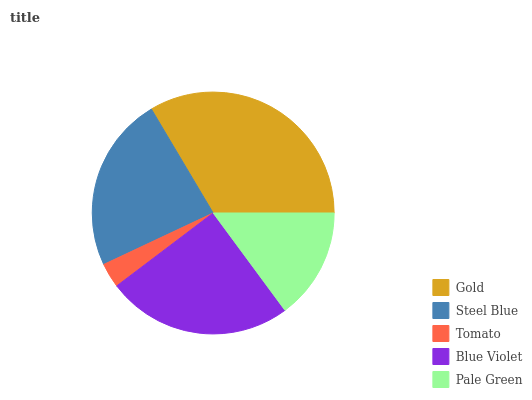Is Tomato the minimum?
Answer yes or no. Yes. Is Gold the maximum?
Answer yes or no. Yes. Is Steel Blue the minimum?
Answer yes or no. No. Is Steel Blue the maximum?
Answer yes or no. No. Is Gold greater than Steel Blue?
Answer yes or no. Yes. Is Steel Blue less than Gold?
Answer yes or no. Yes. Is Steel Blue greater than Gold?
Answer yes or no. No. Is Gold less than Steel Blue?
Answer yes or no. No. Is Steel Blue the high median?
Answer yes or no. Yes. Is Steel Blue the low median?
Answer yes or no. Yes. Is Pale Green the high median?
Answer yes or no. No. Is Gold the low median?
Answer yes or no. No. 